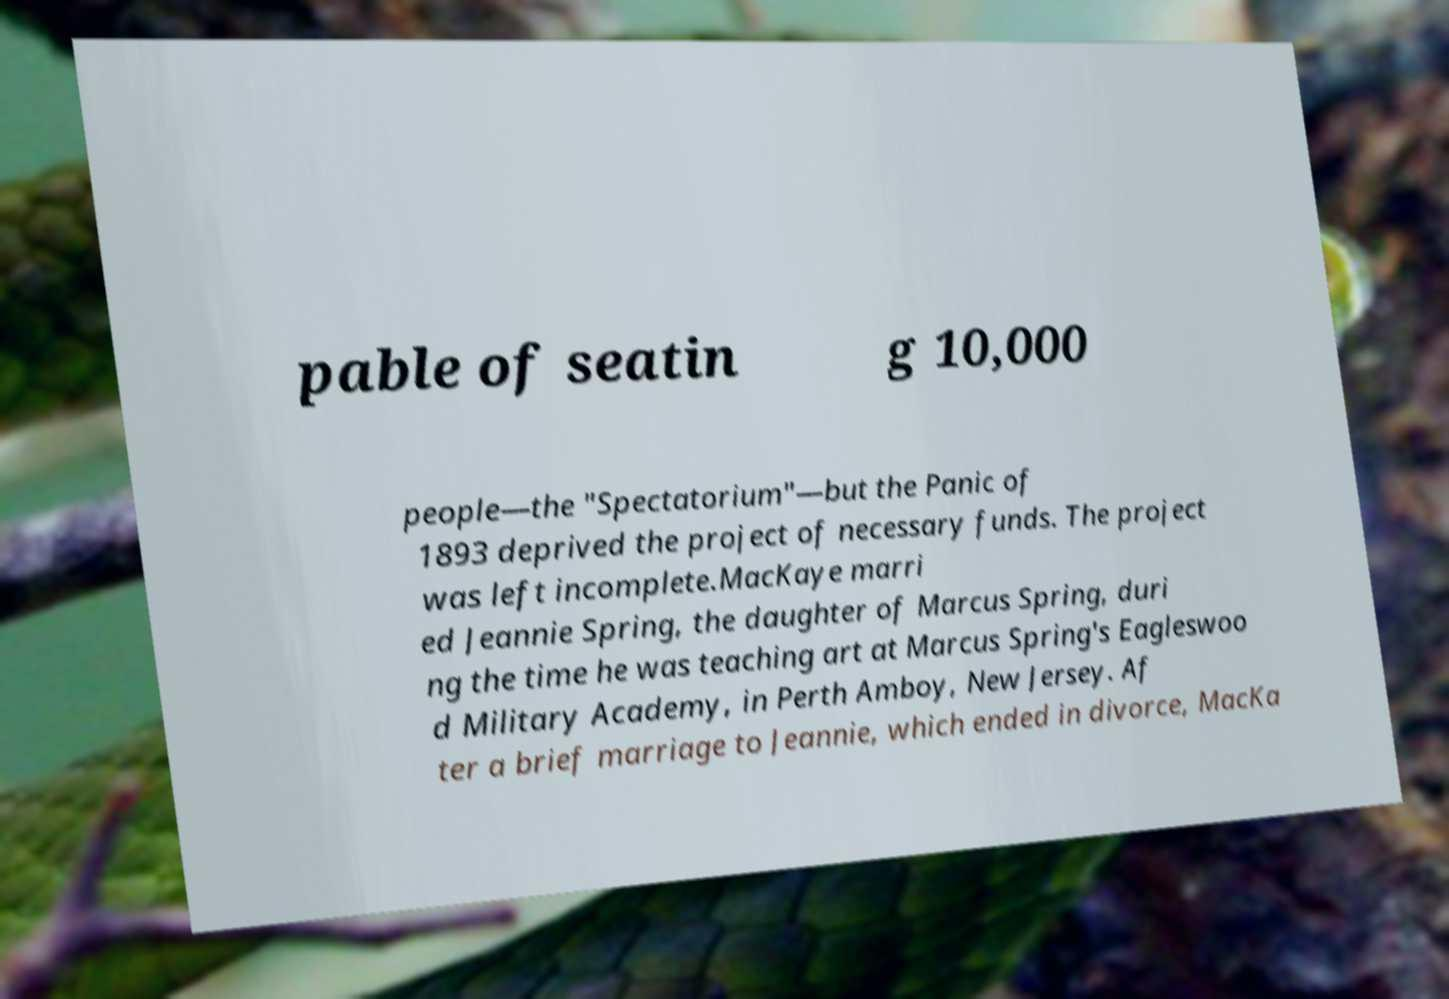I need the written content from this picture converted into text. Can you do that? pable of seatin g 10,000 people—the "Spectatorium"—but the Panic of 1893 deprived the project of necessary funds. The project was left incomplete.MacKaye marri ed Jeannie Spring, the daughter of Marcus Spring, duri ng the time he was teaching art at Marcus Spring's Eagleswoo d Military Academy, in Perth Amboy, New Jersey. Af ter a brief marriage to Jeannie, which ended in divorce, MacKa 